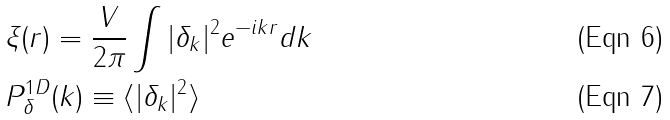Convert formula to latex. <formula><loc_0><loc_0><loc_500><loc_500>& \xi ( r ) = \frac { V } { 2 \pi } \int | \delta _ { k } | ^ { 2 } e ^ { - i k r } d k \\ & P ^ { 1 D } _ { \delta } ( k ) \equiv \langle | \delta _ { k } | ^ { 2 } \rangle</formula> 